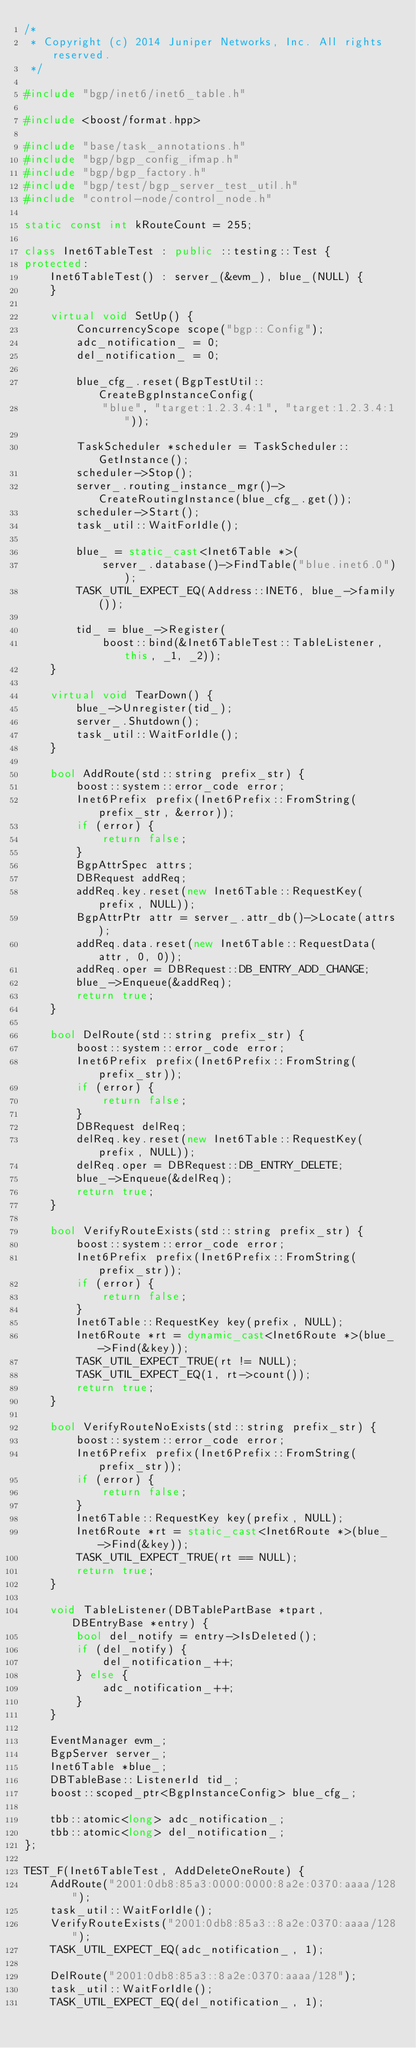<code> <loc_0><loc_0><loc_500><loc_500><_C++_>/*
 * Copyright (c) 2014 Juniper Networks, Inc. All rights reserved.
 */

#include "bgp/inet6/inet6_table.h"

#include <boost/format.hpp>

#include "base/task_annotations.h"
#include "bgp/bgp_config_ifmap.h"
#include "bgp/bgp_factory.h"
#include "bgp/test/bgp_server_test_util.h"
#include "control-node/control_node.h"

static const int kRouteCount = 255;

class Inet6TableTest : public ::testing::Test {
protected:
    Inet6TableTest() : server_(&evm_), blue_(NULL) {
    }

    virtual void SetUp() {
        ConcurrencyScope scope("bgp::Config");
        adc_notification_ = 0;
        del_notification_ = 0;

        blue_cfg_.reset(BgpTestUtil::CreateBgpInstanceConfig(
            "blue", "target:1.2.3.4:1", "target:1.2.3.4:1"));

        TaskScheduler *scheduler = TaskScheduler::GetInstance();
        scheduler->Stop();
        server_.routing_instance_mgr()->CreateRoutingInstance(blue_cfg_.get());
        scheduler->Start();
        task_util::WaitForIdle();

        blue_ = static_cast<Inet6Table *>(
            server_.database()->FindTable("blue.inet6.0"));
        TASK_UTIL_EXPECT_EQ(Address::INET6, blue_->family());

        tid_ = blue_->Register(
            boost::bind(&Inet6TableTest::TableListener, this, _1, _2));
    }

    virtual void TearDown() {
        blue_->Unregister(tid_);
        server_.Shutdown();
        task_util::WaitForIdle();
    }

    bool AddRoute(std::string prefix_str) {
        boost::system::error_code error;
        Inet6Prefix prefix(Inet6Prefix::FromString(prefix_str, &error));
        if (error) {
            return false;
        }
        BgpAttrSpec attrs;
        DBRequest addReq;
        addReq.key.reset(new Inet6Table::RequestKey(prefix, NULL));
        BgpAttrPtr attr = server_.attr_db()->Locate(attrs);
        addReq.data.reset(new Inet6Table::RequestData(attr, 0, 0));
        addReq.oper = DBRequest::DB_ENTRY_ADD_CHANGE;
        blue_->Enqueue(&addReq);
        return true;
    }

    bool DelRoute(std::string prefix_str) {
        boost::system::error_code error;
        Inet6Prefix prefix(Inet6Prefix::FromString(prefix_str));
        if (error) {
            return false;
        }
        DBRequest delReq;
        delReq.key.reset(new Inet6Table::RequestKey(prefix, NULL));
        delReq.oper = DBRequest::DB_ENTRY_DELETE;
        blue_->Enqueue(&delReq);
        return true;
    }

    bool VerifyRouteExists(std::string prefix_str) {
        boost::system::error_code error;
        Inet6Prefix prefix(Inet6Prefix::FromString(prefix_str));
        if (error) {
            return false;
        }
        Inet6Table::RequestKey key(prefix, NULL);
        Inet6Route *rt = dynamic_cast<Inet6Route *>(blue_->Find(&key));
        TASK_UTIL_EXPECT_TRUE(rt != NULL);
        TASK_UTIL_EXPECT_EQ(1, rt->count());
        return true;
    }

    bool VerifyRouteNoExists(std::string prefix_str) {
        boost::system::error_code error;
        Inet6Prefix prefix(Inet6Prefix::FromString(prefix_str));
        if (error) {
            return false;
        }
        Inet6Table::RequestKey key(prefix, NULL);
        Inet6Route *rt = static_cast<Inet6Route *>(blue_->Find(&key));
        TASK_UTIL_EXPECT_TRUE(rt == NULL);
        return true;
    }

    void TableListener(DBTablePartBase *tpart, DBEntryBase *entry) {
        bool del_notify = entry->IsDeleted();
        if (del_notify) {
            del_notification_++;
        } else {
            adc_notification_++;
        }
    }

    EventManager evm_;
    BgpServer server_;
    Inet6Table *blue_;
    DBTableBase::ListenerId tid_;
    boost::scoped_ptr<BgpInstanceConfig> blue_cfg_;

    tbb::atomic<long> adc_notification_;
    tbb::atomic<long> del_notification_;
};

TEST_F(Inet6TableTest, AddDeleteOneRoute) {
    AddRoute("2001:0db8:85a3:0000:0000:8a2e:0370:aaaa/128");
    task_util::WaitForIdle();
    VerifyRouteExists("2001:0db8:85a3::8a2e:0370:aaaa/128");
    TASK_UTIL_EXPECT_EQ(adc_notification_, 1);

    DelRoute("2001:0db8:85a3::8a2e:0370:aaaa/128");
    task_util::WaitForIdle();
    TASK_UTIL_EXPECT_EQ(del_notification_, 1);</code> 